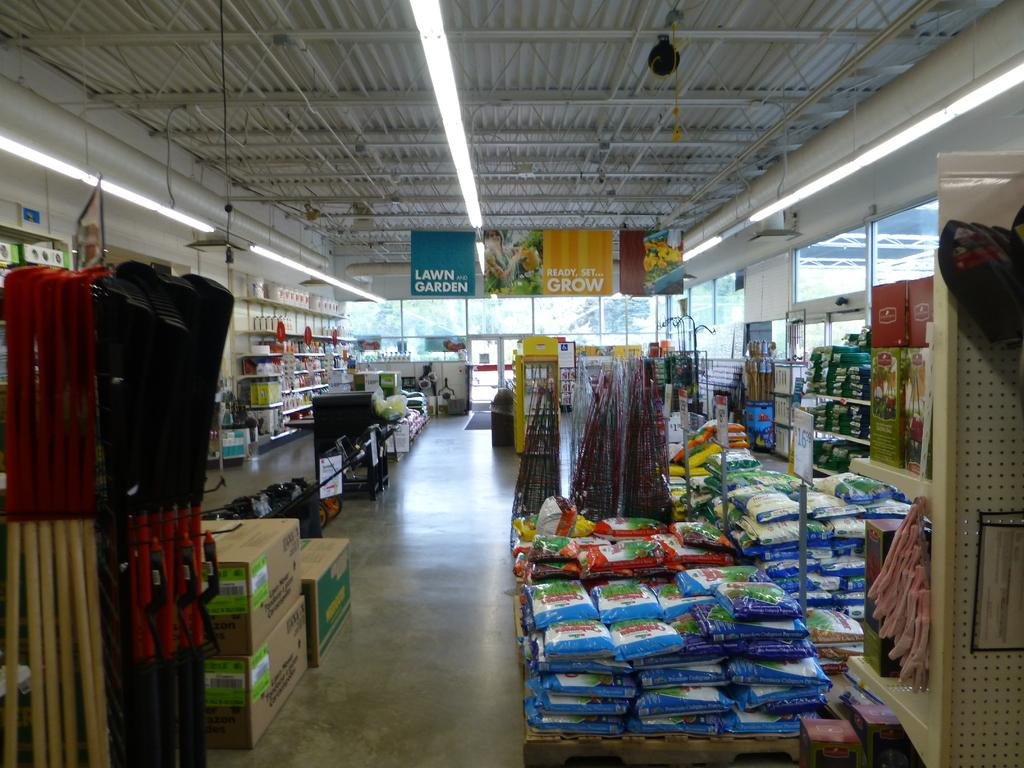<image>
Summarize the visual content of the image. A home and garden store one sign reads lawn and garden the other sign reads ready, set, grow/ 